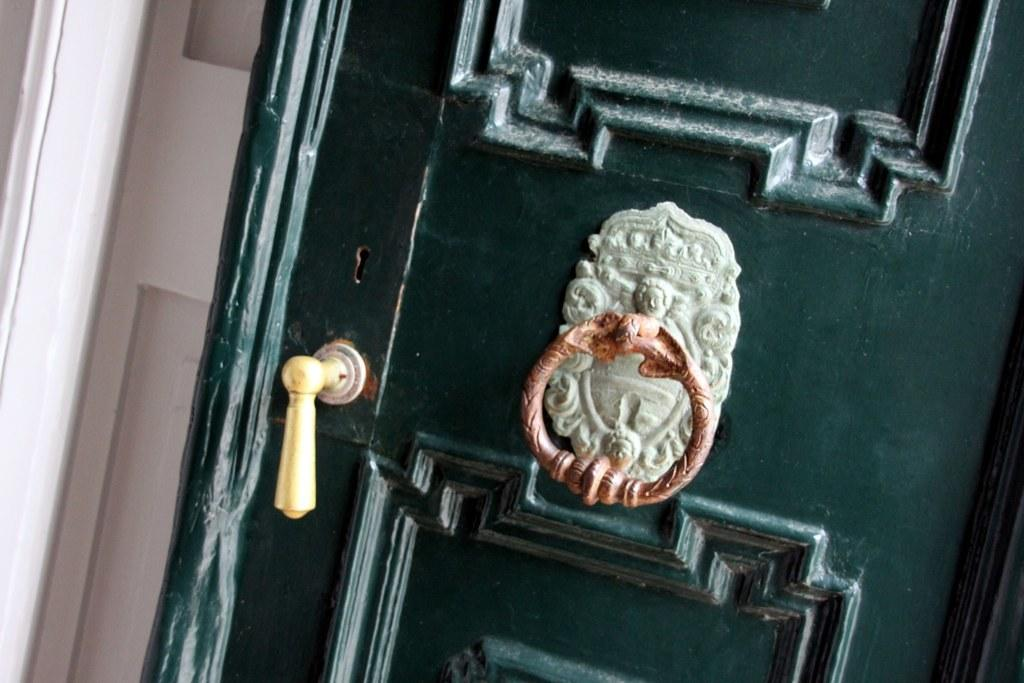What is the main object in the image? There is a door in the image. Is there anything attached to the door for assistance? Yes, there is a handle stick for support on the door. What type of cushion is placed on the chin of the person in the image? There is no person or cushion present in the image; it only features a door with a handle stick. 